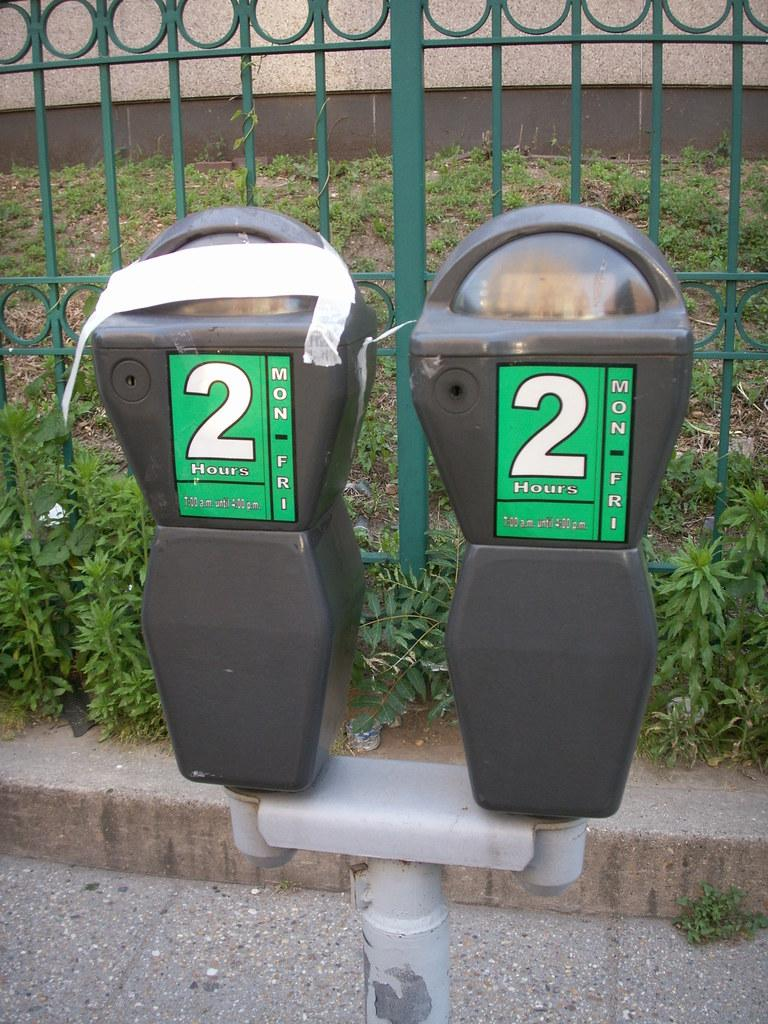<image>
Create a compact narrative representing the image presented. Two parking meters that say 2 Hours are by a green fence. 